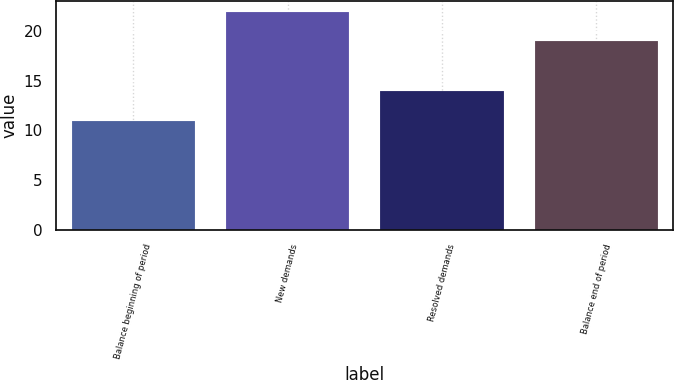Convert chart to OTSL. <chart><loc_0><loc_0><loc_500><loc_500><bar_chart><fcel>Balance beginning of period<fcel>New demands<fcel>Resolved demands<fcel>Balance end of period<nl><fcel>11<fcel>22<fcel>14<fcel>19<nl></chart> 